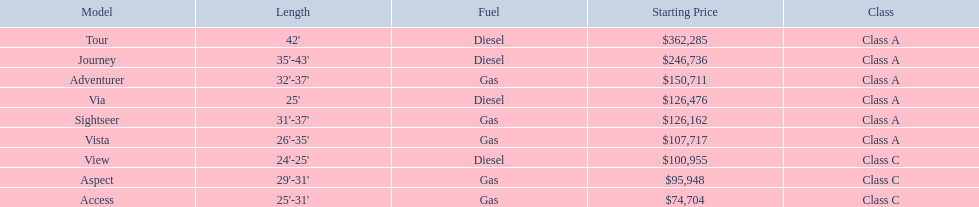What is the highest price of a winnebago model? $362,285. What is the name of the vehicle with this price? Tour. 